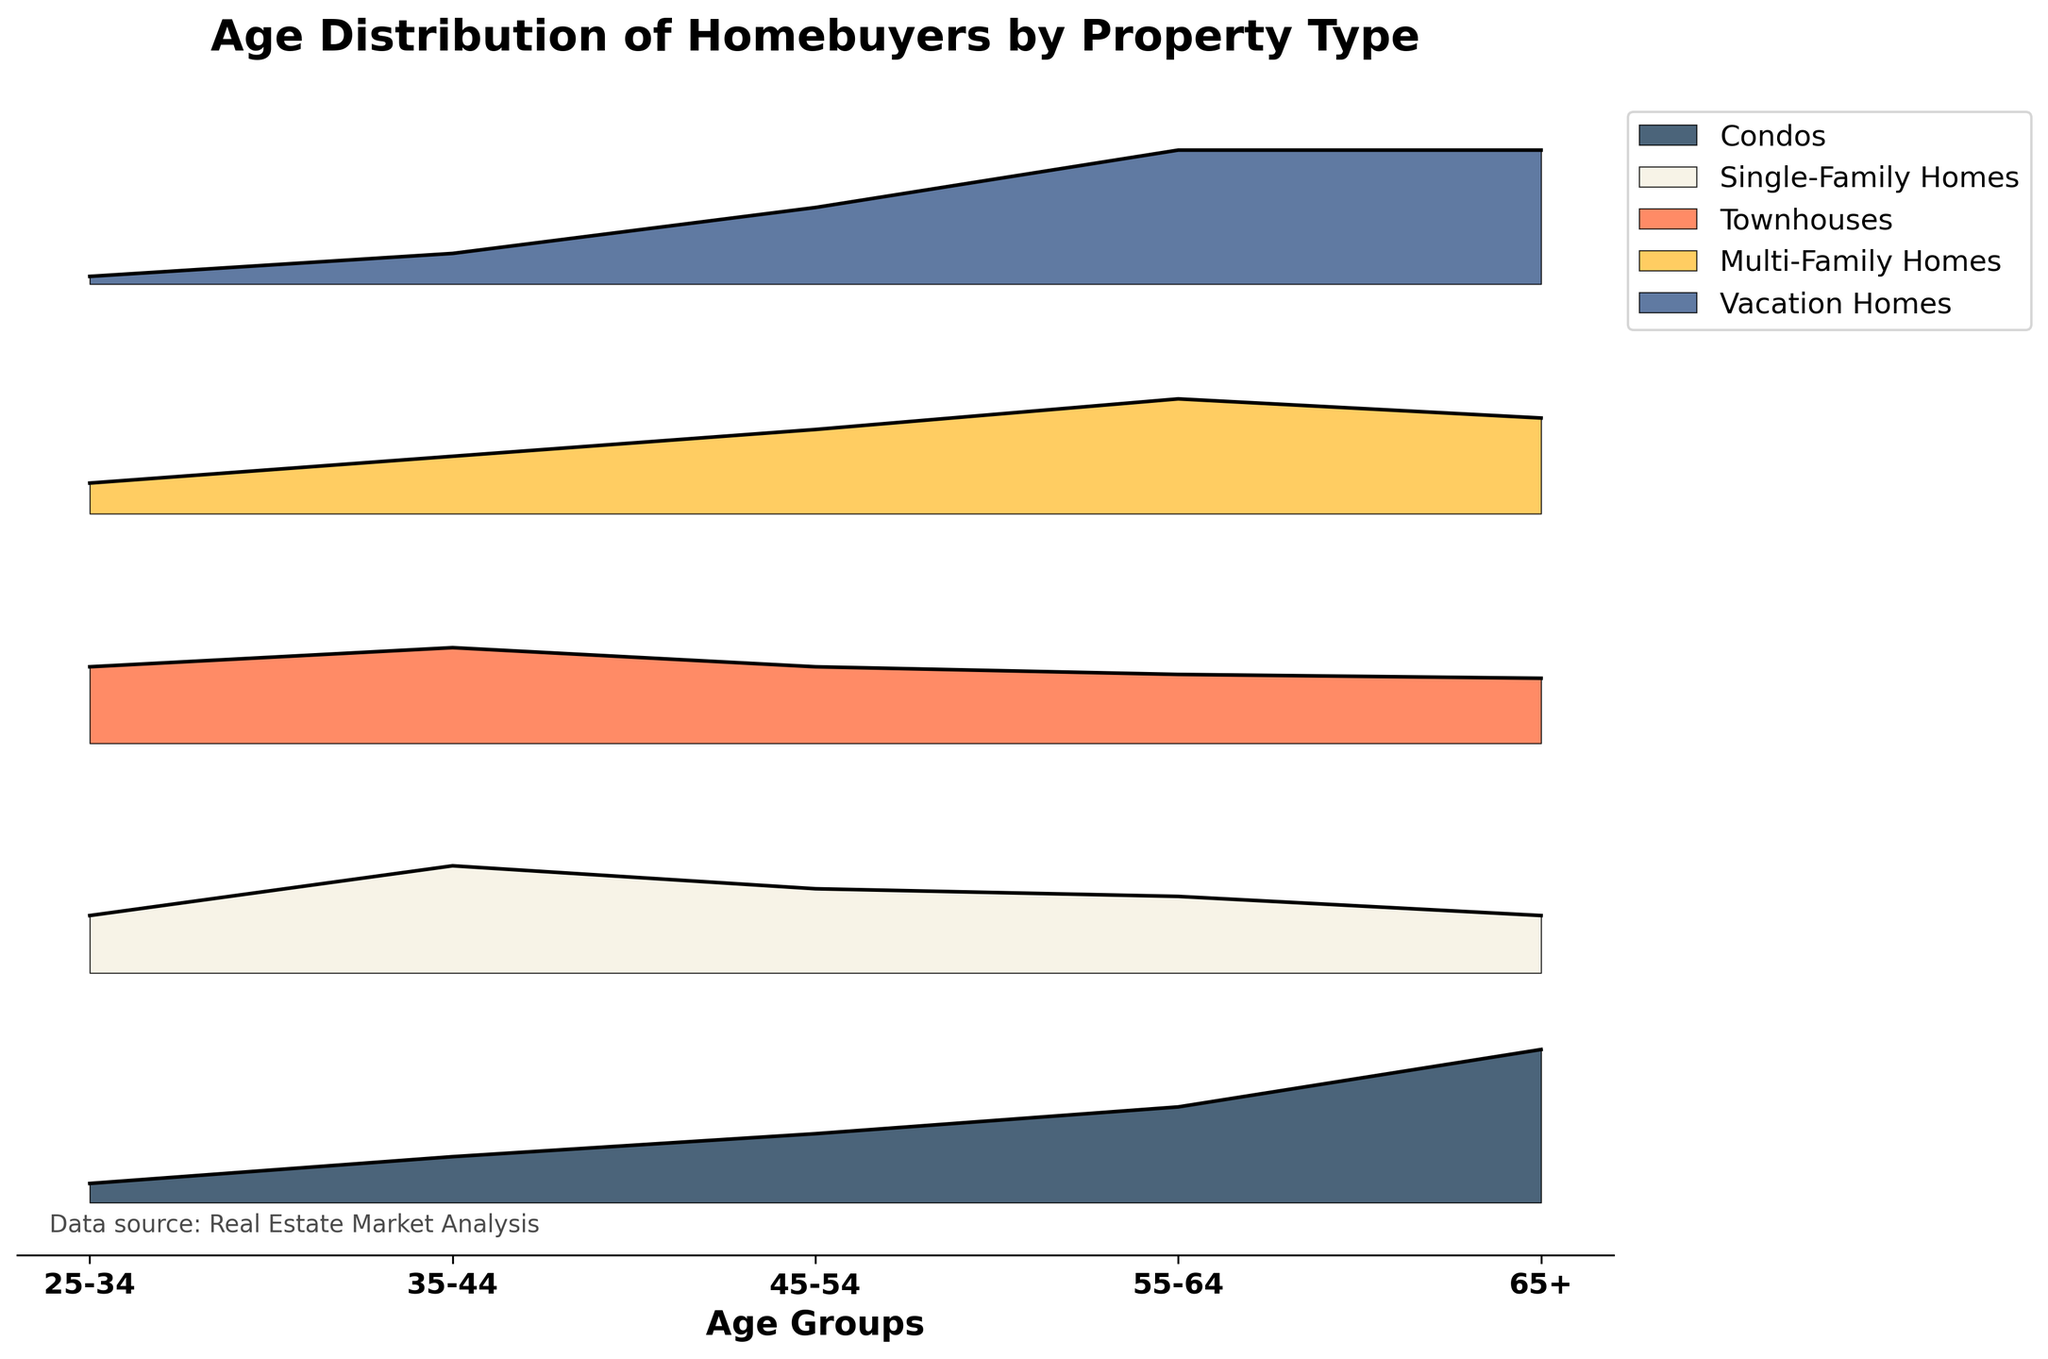What is the title of the figure? The title is located at the top of the figure and usually gives a brief description of what the figure shows. It reads "Age Distribution of Homebuyers by Property Type".
Answer: Age Distribution of Homebuyers by Property Type What age group has the highest density for Condos? Look at the area with the highest peak for the Condos line on the Ridgeline plot. The age group with the highest peak indicates the highest density. For Condos, the peak is at the age group 65+.
Answer: 65+ Which property type shows the highest density for the age group 25-34? Observe the density values on the Ridgeline plot for each property type at the specific age group 25-34. The property type with the highest bump is the one with the highest density. The density value for Townhouses at 25-34 is the highest.
Answer: Townhouses How do the densities for Single-Family Homes and Vacation Homes compare in the 55-64 age group? Compare the heights of the density peaks for Single-Family Homes and Vacation Homes within the age group 55-64 on the plot. Single-Family Homes show a peak at 0.20 while Vacation Homes show a peak at 0.35. Therefore, Vacation Homes have a higher density.
Answer: Vacation Homes have a higher density Is the density distribution for Townhouses more uniform across age groups compared to Condos? Check the height variance of densities across age groups for both Townhouses and Condos in the plot. Townhouses show a more balanced density across all age groups while Condos have a significant peak in the 65+ age group.
Answer: Yes Which property type has the most balanced density distribution across age groups? Look at the height of the peaks for each property type across different age groups and identify the one with relatively consistent heights. Townhouses appear to have the most uniform distribution.
Answer: Townhouses What is the density value for Vacation Homes in the 45-54 age group? Locate the corresponding peak for Vacation Homes within the 45-54 age group on the plot. The density value can be read right off the plot.
Answer: 0.20 Which two age groups share the same highest density value for Vacation Homes? Look at the Vacation Homes' peaks on the plot and identify which age groups have the same height. 55-64 and 65+ age groups both share a peak of 0.35.
Answer: 55-64 and 65+ How does the density for Multi-Family Homes in the 45-54 age group compare to the 55-64 age group? Compare the heights of the density peaks for Multi-Family Homes between the 45-54 and 55-64 age groups. The peak at 55-64 is visibly higher than the peak at 45-54.
Answer: Higher in 55-64 